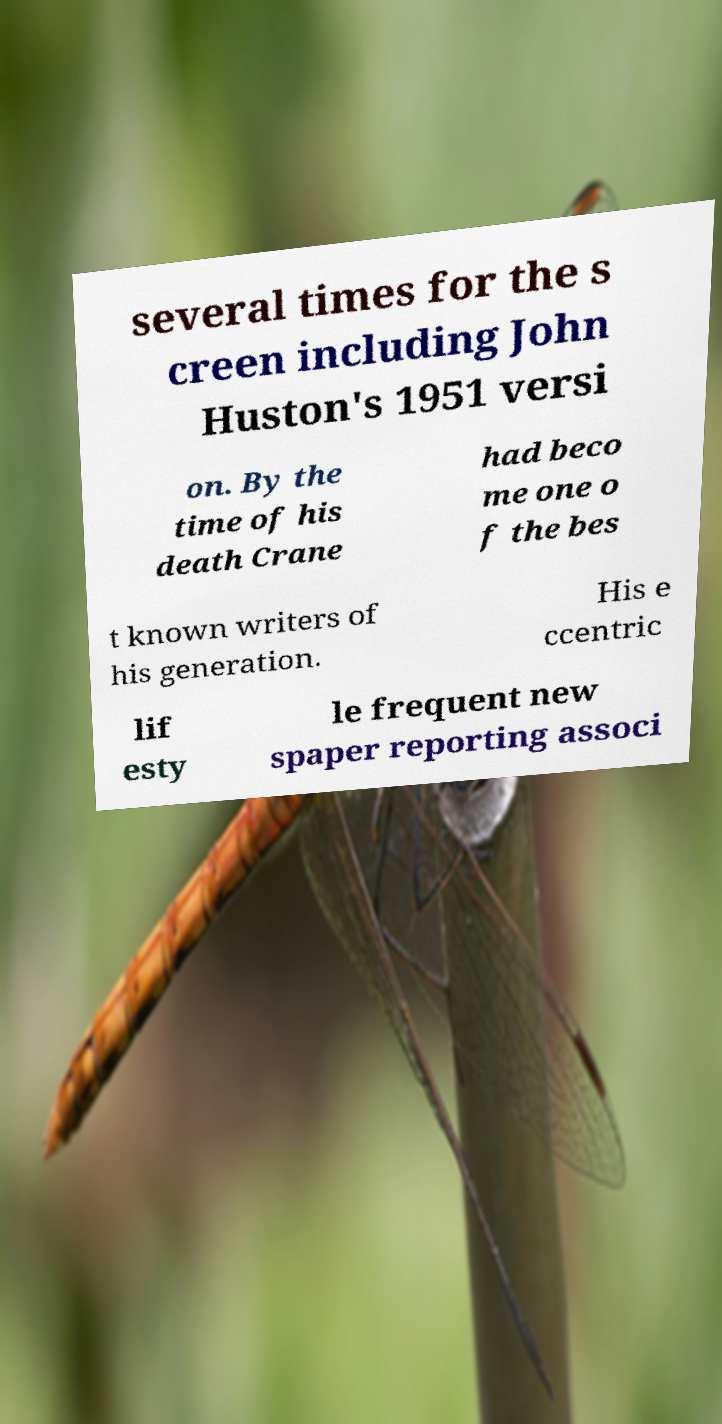Could you assist in decoding the text presented in this image and type it out clearly? several times for the s creen including John Huston's 1951 versi on. By the time of his death Crane had beco me one o f the bes t known writers of his generation. His e ccentric lif esty le frequent new spaper reporting associ 